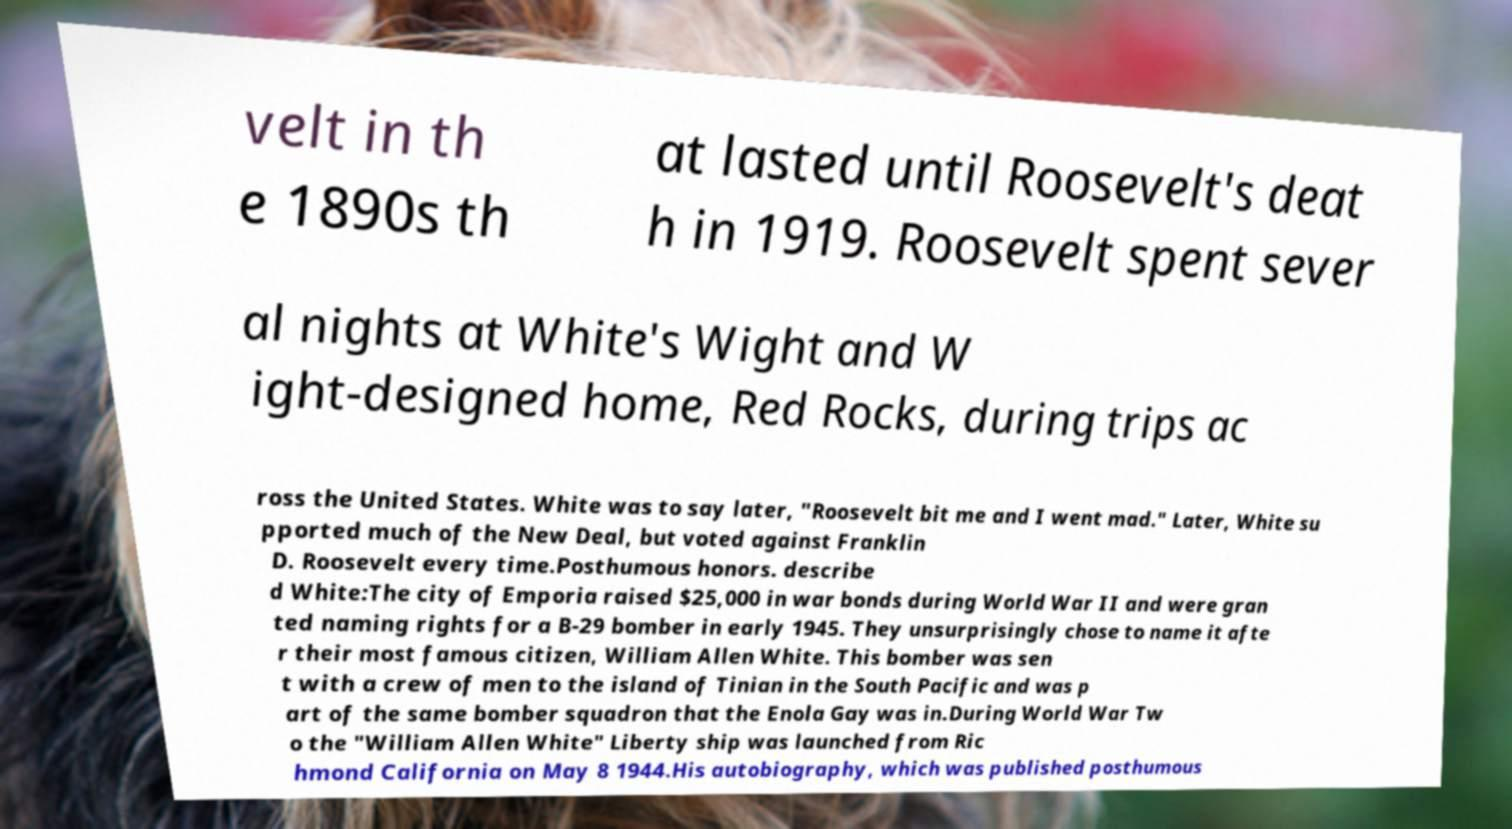There's text embedded in this image that I need extracted. Can you transcribe it verbatim? velt in th e 1890s th at lasted until Roosevelt's deat h in 1919. Roosevelt spent sever al nights at White's Wight and W ight-designed home, Red Rocks, during trips ac ross the United States. White was to say later, "Roosevelt bit me and I went mad." Later, White su pported much of the New Deal, but voted against Franklin D. Roosevelt every time.Posthumous honors. describe d White:The city of Emporia raised $25,000 in war bonds during World War II and were gran ted naming rights for a B-29 bomber in early 1945. They unsurprisingly chose to name it afte r their most famous citizen, William Allen White. This bomber was sen t with a crew of men to the island of Tinian in the South Pacific and was p art of the same bomber squadron that the Enola Gay was in.During World War Tw o the "William Allen White" Liberty ship was launched from Ric hmond California on May 8 1944.His autobiography, which was published posthumous 